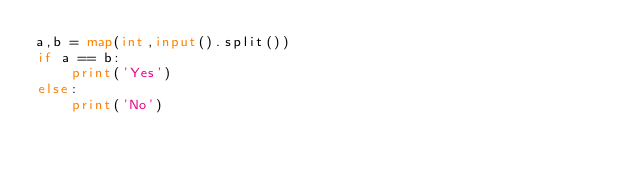<code> <loc_0><loc_0><loc_500><loc_500><_Python_>a,b = map(int,input().split())
if a == b:
    print('Yes')
else:
    print('No')</code> 